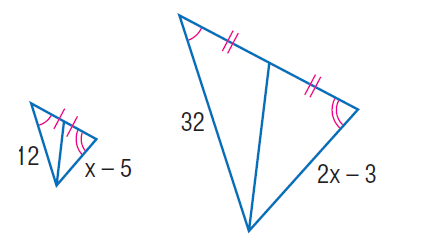Question: Find x.
Choices:
A. 12
B. 15.5
C. 16
D. 19
Answer with the letter. Answer: B 